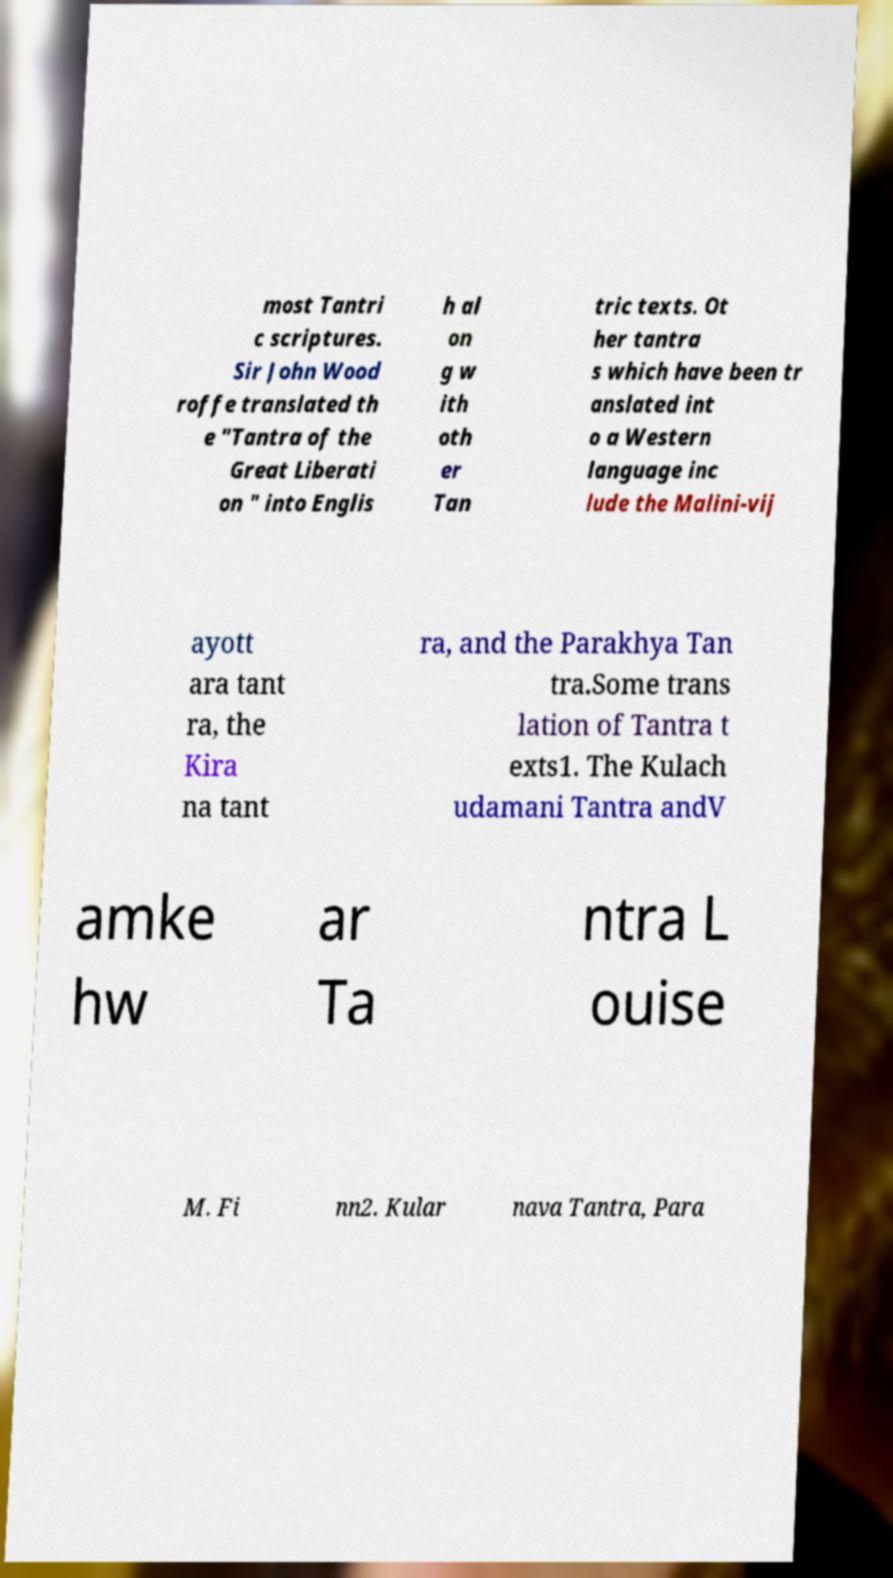For documentation purposes, I need the text within this image transcribed. Could you provide that? most Tantri c scriptures. Sir John Wood roffe translated th e "Tantra of the Great Liberati on " into Englis h al on g w ith oth er Tan tric texts. Ot her tantra s which have been tr anslated int o a Western language inc lude the Malini-vij ayott ara tant ra, the Kira na tant ra, and the Parakhya Tan tra.Some trans lation of Tantra t exts1. The Kulach udamani Tantra andV amke hw ar Ta ntra L ouise M. Fi nn2. Kular nava Tantra, Para 